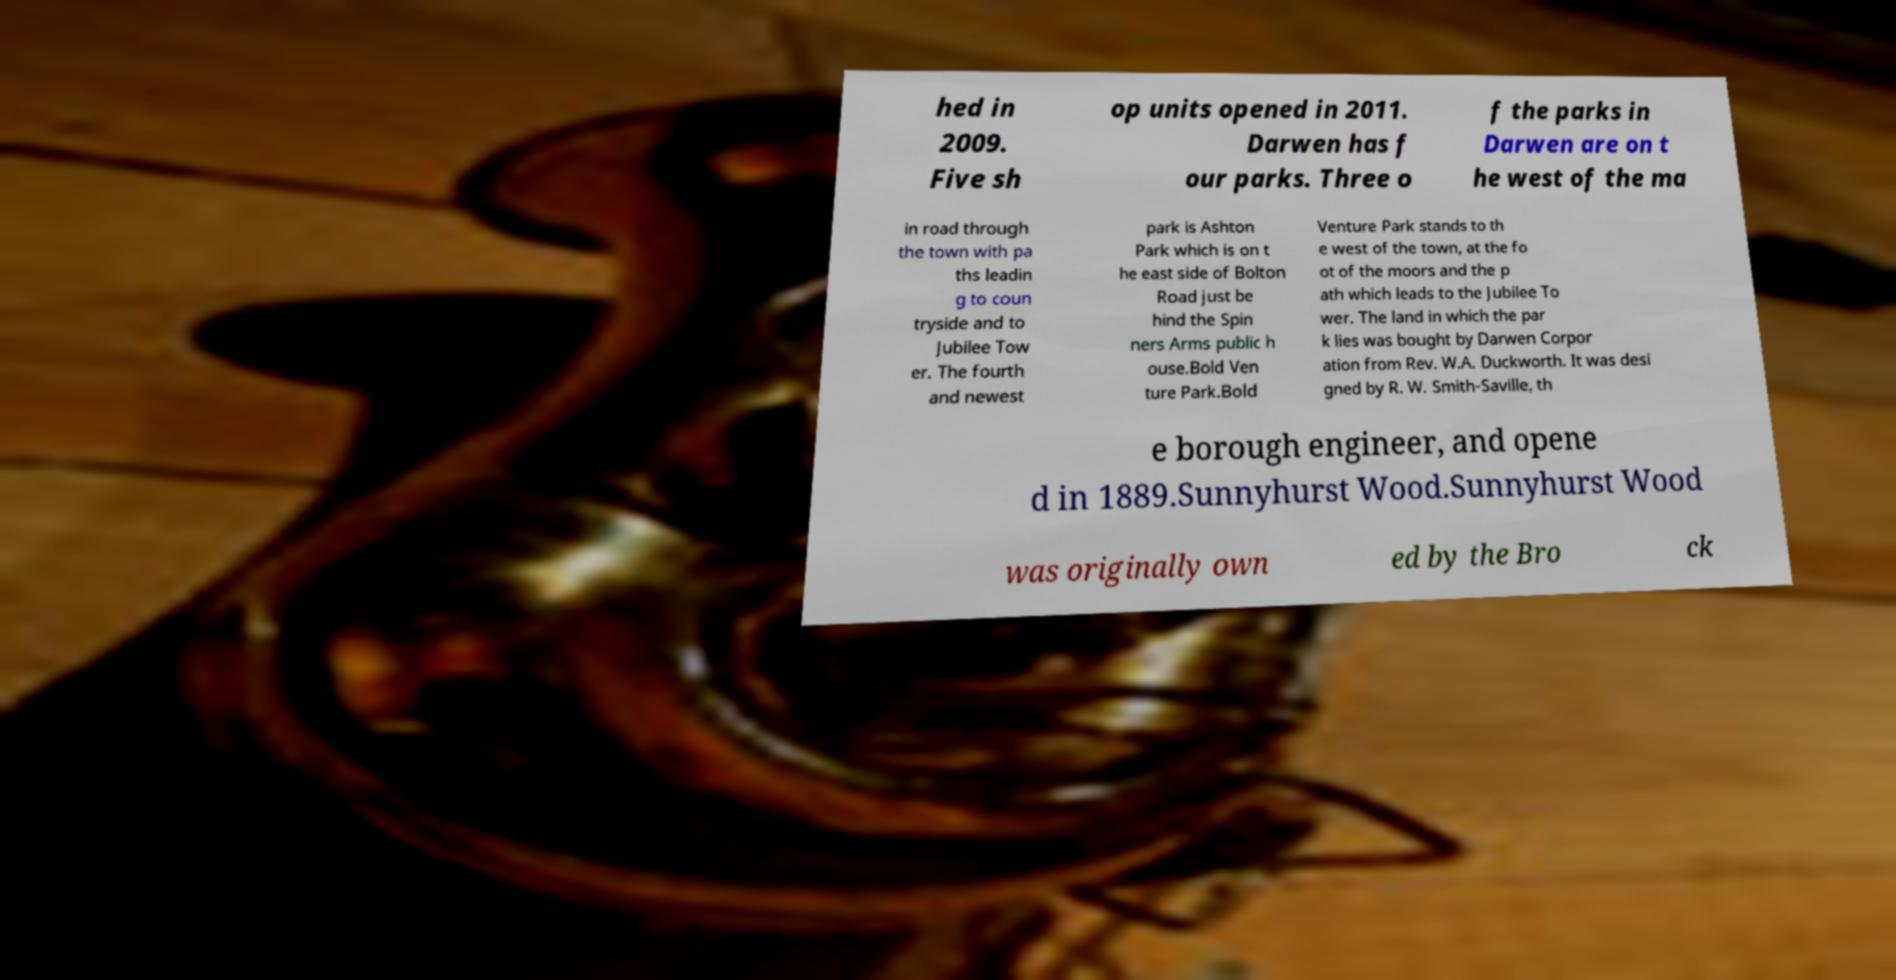There's text embedded in this image that I need extracted. Can you transcribe it verbatim? hed in 2009. Five sh op units opened in 2011. Darwen has f our parks. Three o f the parks in Darwen are on t he west of the ma in road through the town with pa ths leadin g to coun tryside and to Jubilee Tow er. The fourth and newest park is Ashton Park which is on t he east side of Bolton Road just be hind the Spin ners Arms public h ouse.Bold Ven ture Park.Bold Venture Park stands to th e west of the town, at the fo ot of the moors and the p ath which leads to the Jubilee To wer. The land in which the par k lies was bought by Darwen Corpor ation from Rev. W.A. Duckworth. It was desi gned by R. W. Smith-Saville, th e borough engineer, and opene d in 1889.Sunnyhurst Wood.Sunnyhurst Wood was originally own ed by the Bro ck 